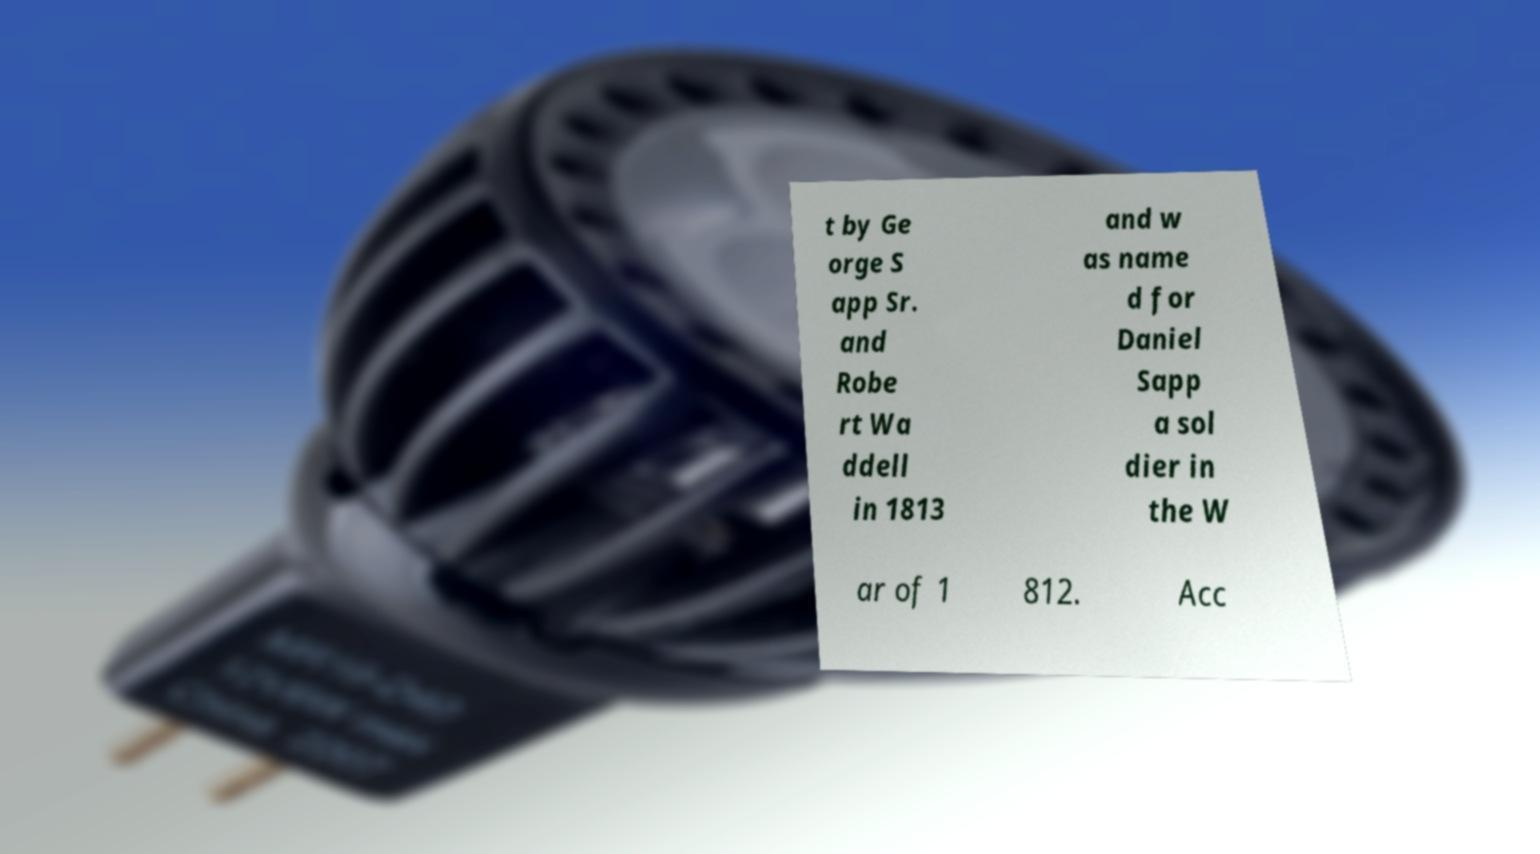Could you assist in decoding the text presented in this image and type it out clearly? t by Ge orge S app Sr. and Robe rt Wa ddell in 1813 and w as name d for Daniel Sapp a sol dier in the W ar of 1 812. Acc 